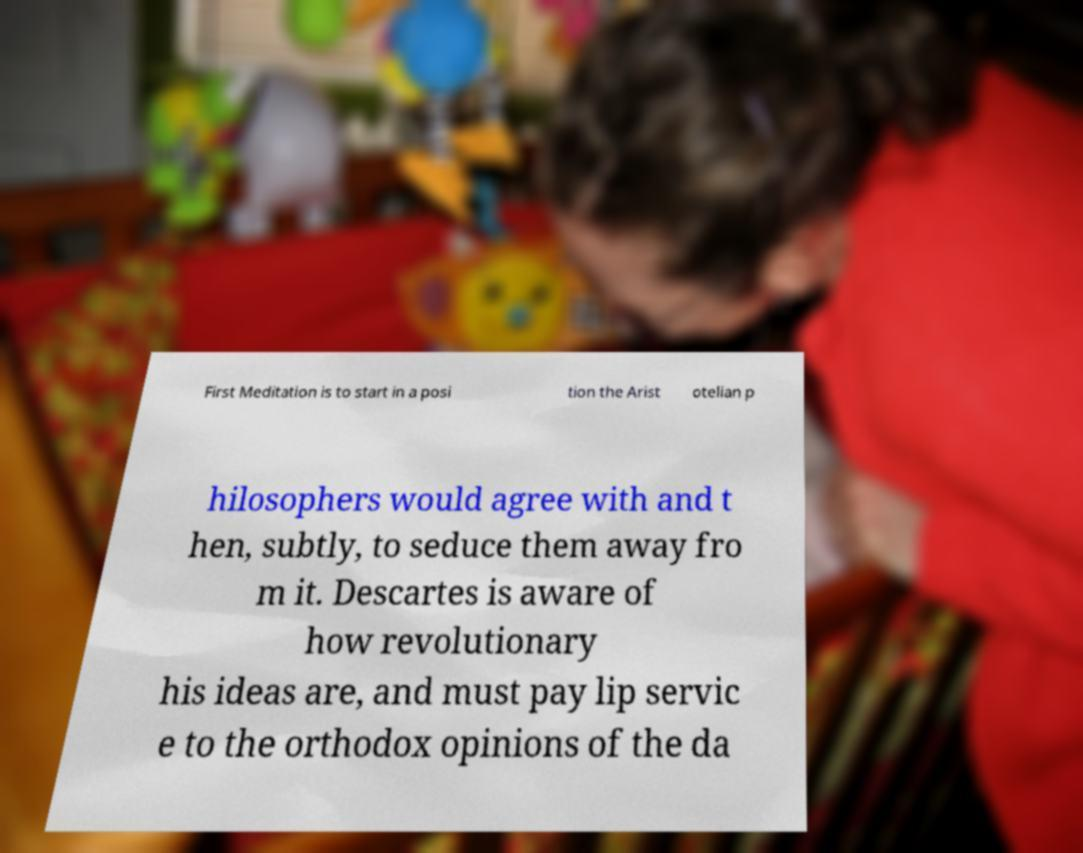For documentation purposes, I need the text within this image transcribed. Could you provide that? First Meditation is to start in a posi tion the Arist otelian p hilosophers would agree with and t hen, subtly, to seduce them away fro m it. Descartes is aware of how revolutionary his ideas are, and must pay lip servic e to the orthodox opinions of the da 